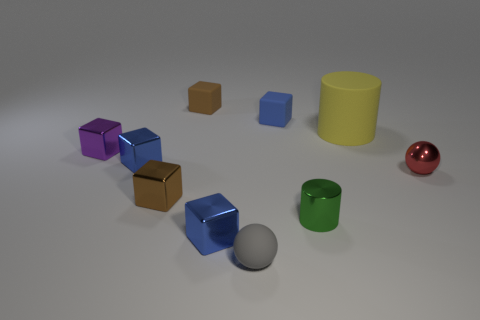Subtract all brown cylinders. How many blue blocks are left? 3 Subtract all tiny brown cubes. How many cubes are left? 4 Subtract all purple blocks. How many blocks are left? 5 Subtract all yellow blocks. Subtract all blue spheres. How many blocks are left? 6 Subtract all cubes. How many objects are left? 4 Add 8 small green cylinders. How many small green cylinders exist? 9 Subtract 0 green spheres. How many objects are left? 10 Subtract all big blue spheres. Subtract all tiny red metallic objects. How many objects are left? 9 Add 6 small blue rubber blocks. How many small blue rubber blocks are left? 7 